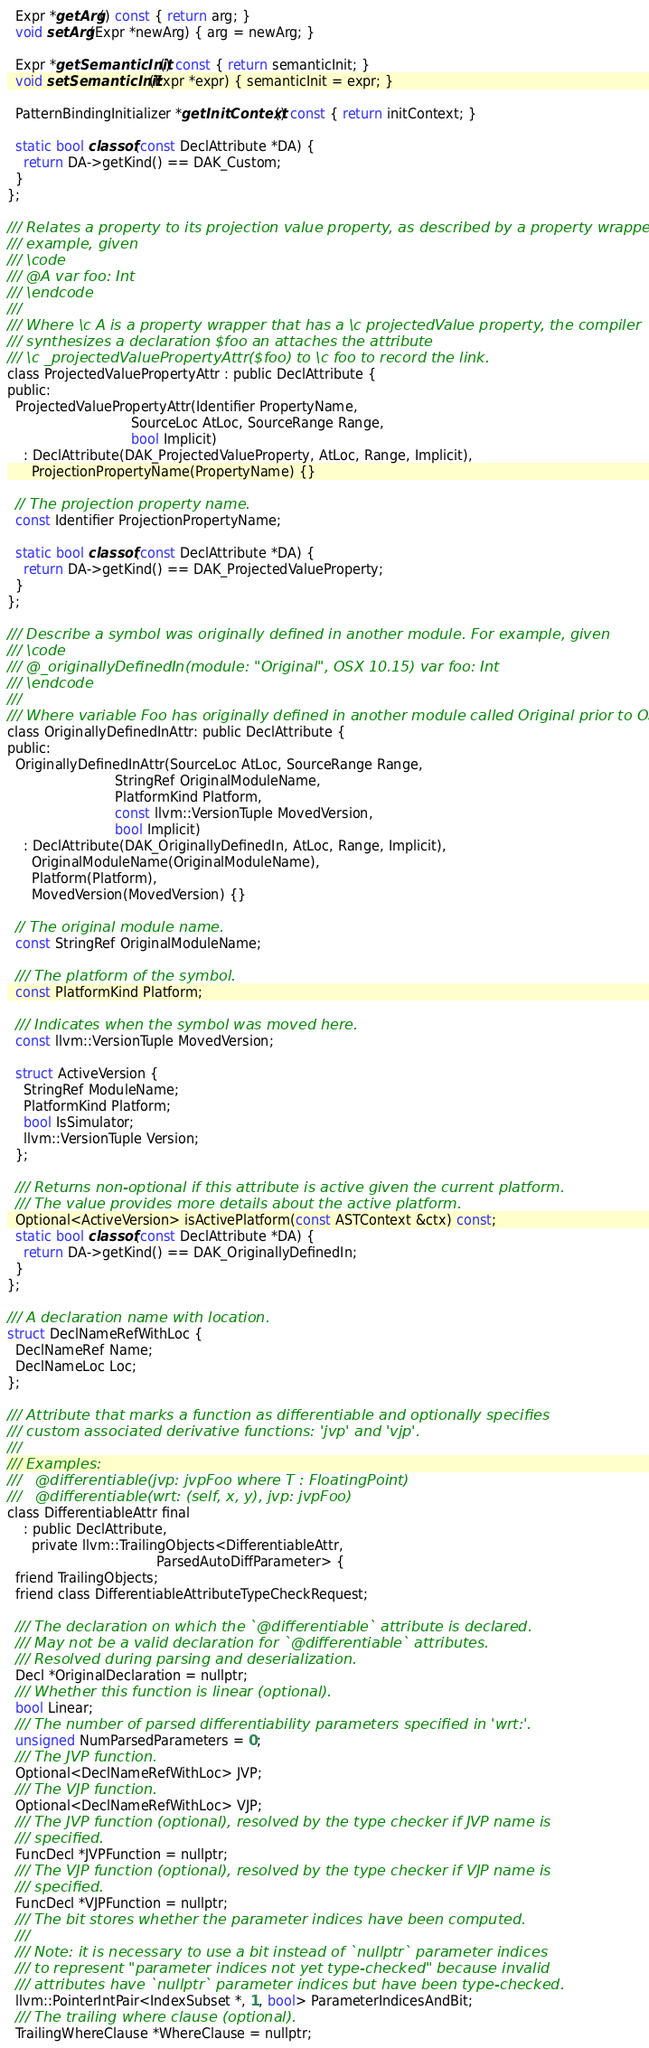Convert code to text. <code><loc_0><loc_0><loc_500><loc_500><_C_>
  Expr *getArg() const { return arg; }
  void setArg(Expr *newArg) { arg = newArg; }

  Expr *getSemanticInit() const { return semanticInit; }
  void setSemanticInit(Expr *expr) { semanticInit = expr; }

  PatternBindingInitializer *getInitContext() const { return initContext; }

  static bool classof(const DeclAttribute *DA) {
    return DA->getKind() == DAK_Custom;
  }
};

/// Relates a property to its projection value property, as described by a property wrapper. For
/// example, given
/// \code
/// @A var foo: Int
/// \endcode
///
/// Where \c A is a property wrapper that has a \c projectedValue property, the compiler
/// synthesizes a declaration $foo an attaches the attribute
/// \c _projectedValuePropertyAttr($foo) to \c foo to record the link.
class ProjectedValuePropertyAttr : public DeclAttribute {
public:
  ProjectedValuePropertyAttr(Identifier PropertyName,
                              SourceLoc AtLoc, SourceRange Range,
                              bool Implicit)
    : DeclAttribute(DAK_ProjectedValueProperty, AtLoc, Range, Implicit),
      ProjectionPropertyName(PropertyName) {}

  // The projection property name.
  const Identifier ProjectionPropertyName;

  static bool classof(const DeclAttribute *DA) {
    return DA->getKind() == DAK_ProjectedValueProperty;
  }
};

/// Describe a symbol was originally defined in another module. For example, given
/// \code
/// @_originallyDefinedIn(module: "Original", OSX 10.15) var foo: Int
/// \endcode
///
/// Where variable Foo has originally defined in another module called Original prior to OSX 10.15
class OriginallyDefinedInAttr: public DeclAttribute {
public:
  OriginallyDefinedInAttr(SourceLoc AtLoc, SourceRange Range,
                          StringRef OriginalModuleName,
                          PlatformKind Platform,
                          const llvm::VersionTuple MovedVersion,
                          bool Implicit)
    : DeclAttribute(DAK_OriginallyDefinedIn, AtLoc, Range, Implicit),
      OriginalModuleName(OriginalModuleName),
      Platform(Platform),
      MovedVersion(MovedVersion) {}

  // The original module name.
  const StringRef OriginalModuleName;

  /// The platform of the symbol.
  const PlatformKind Platform;

  /// Indicates when the symbol was moved here.
  const llvm::VersionTuple MovedVersion;

  struct ActiveVersion {
    StringRef ModuleName;
    PlatformKind Platform;
    bool IsSimulator;
    llvm::VersionTuple Version;
  };

  /// Returns non-optional if this attribute is active given the current platform.
  /// The value provides more details about the active platform.
  Optional<ActiveVersion> isActivePlatform(const ASTContext &ctx) const;
  static bool classof(const DeclAttribute *DA) {
    return DA->getKind() == DAK_OriginallyDefinedIn;
  }
};

/// A declaration name with location.
struct DeclNameRefWithLoc {
  DeclNameRef Name;
  DeclNameLoc Loc;
};

/// Attribute that marks a function as differentiable and optionally specifies
/// custom associated derivative functions: 'jvp' and 'vjp'.
///
/// Examples:
///   @differentiable(jvp: jvpFoo where T : FloatingPoint)
///   @differentiable(wrt: (self, x, y), jvp: jvpFoo)
class DifferentiableAttr final
    : public DeclAttribute,
      private llvm::TrailingObjects<DifferentiableAttr,
                                    ParsedAutoDiffParameter> {
  friend TrailingObjects;
  friend class DifferentiableAttributeTypeCheckRequest;

  /// The declaration on which the `@differentiable` attribute is declared.
  /// May not be a valid declaration for `@differentiable` attributes.
  /// Resolved during parsing and deserialization.
  Decl *OriginalDeclaration = nullptr;
  /// Whether this function is linear (optional).
  bool Linear;
  /// The number of parsed differentiability parameters specified in 'wrt:'.
  unsigned NumParsedParameters = 0;
  /// The JVP function.
  Optional<DeclNameRefWithLoc> JVP;
  /// The VJP function.
  Optional<DeclNameRefWithLoc> VJP;
  /// The JVP function (optional), resolved by the type checker if JVP name is
  /// specified.
  FuncDecl *JVPFunction = nullptr;
  /// The VJP function (optional), resolved by the type checker if VJP name is
  /// specified.
  FuncDecl *VJPFunction = nullptr;
  /// The bit stores whether the parameter indices have been computed.
  ///
  /// Note: it is necessary to use a bit instead of `nullptr` parameter indices
  /// to represent "parameter indices not yet type-checked" because invalid
  /// attributes have `nullptr` parameter indices but have been type-checked.
  llvm::PointerIntPair<IndexSubset *, 1, bool> ParameterIndicesAndBit;
  /// The trailing where clause (optional).
  TrailingWhereClause *WhereClause = nullptr;</code> 